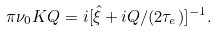Convert formula to latex. <formula><loc_0><loc_0><loc_500><loc_500>\pi \nu _ { 0 } K Q = i [ \hat { \xi } + i Q / ( 2 \tau _ { e } ) ] ^ { - 1 } .</formula> 